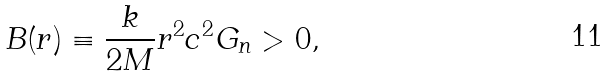<formula> <loc_0><loc_0><loc_500><loc_500>B ( r ) \equiv \frac { k } { 2 M } r ^ { 2 } { c } ^ { 2 } G _ { n } > 0 ,</formula> 